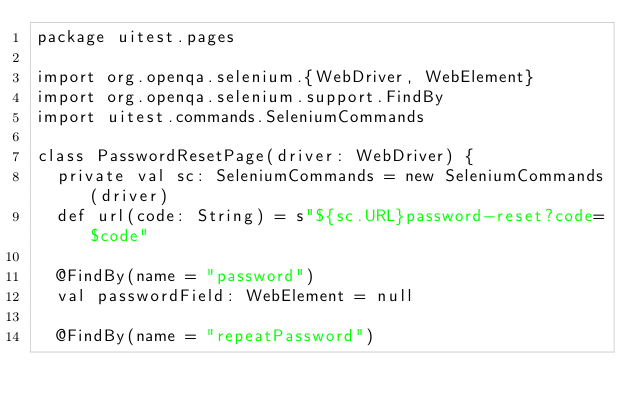Convert code to text. <code><loc_0><loc_0><loc_500><loc_500><_Scala_>package uitest.pages

import org.openqa.selenium.{WebDriver, WebElement}
import org.openqa.selenium.support.FindBy
import uitest.commands.SeleniumCommands

class PasswordResetPage(driver: WebDriver) {
  private val sc: SeleniumCommands = new SeleniumCommands(driver)
  def url(code: String) = s"${sc.URL}password-reset?code=$code"

  @FindBy(name = "password")
  val passwordField: WebElement = null

  @FindBy(name = "repeatPassword")</code> 